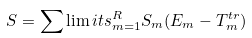Convert formula to latex. <formula><loc_0><loc_0><loc_500><loc_500>S = { \sum \lim i t s _ { m = 1 } ^ { R } } S _ { m } ( E _ { m } - T _ { m } ^ { t r } )</formula> 